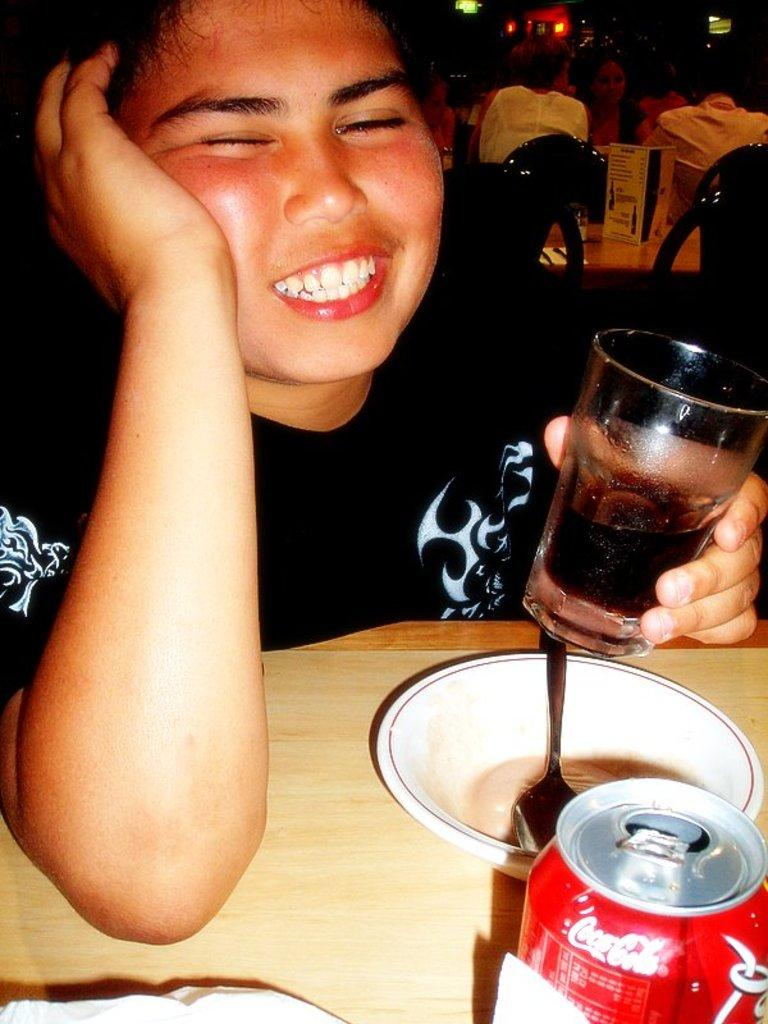What is the person in front of the table holding? The person is holding a glass. What objects can be seen on the table? There is a tin and a bowl with a spoon on the table. How many people are behind the table? There are people behind the table. What furniture is associated with the people behind the table? There are chairs associated with the people behind the table. What type of weather is depicted in the image? There is no indication of weather in the image; it is an indoor scene with a table, chairs, and people. 